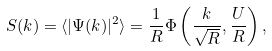Convert formula to latex. <formula><loc_0><loc_0><loc_500><loc_500>S ( k ) = \langle | \Psi ( k ) | ^ { 2 } \rangle = \frac { 1 } { R } \Phi \left ( \frac { k } { \sqrt { R } } , \frac { U } { R } \right ) ,</formula> 